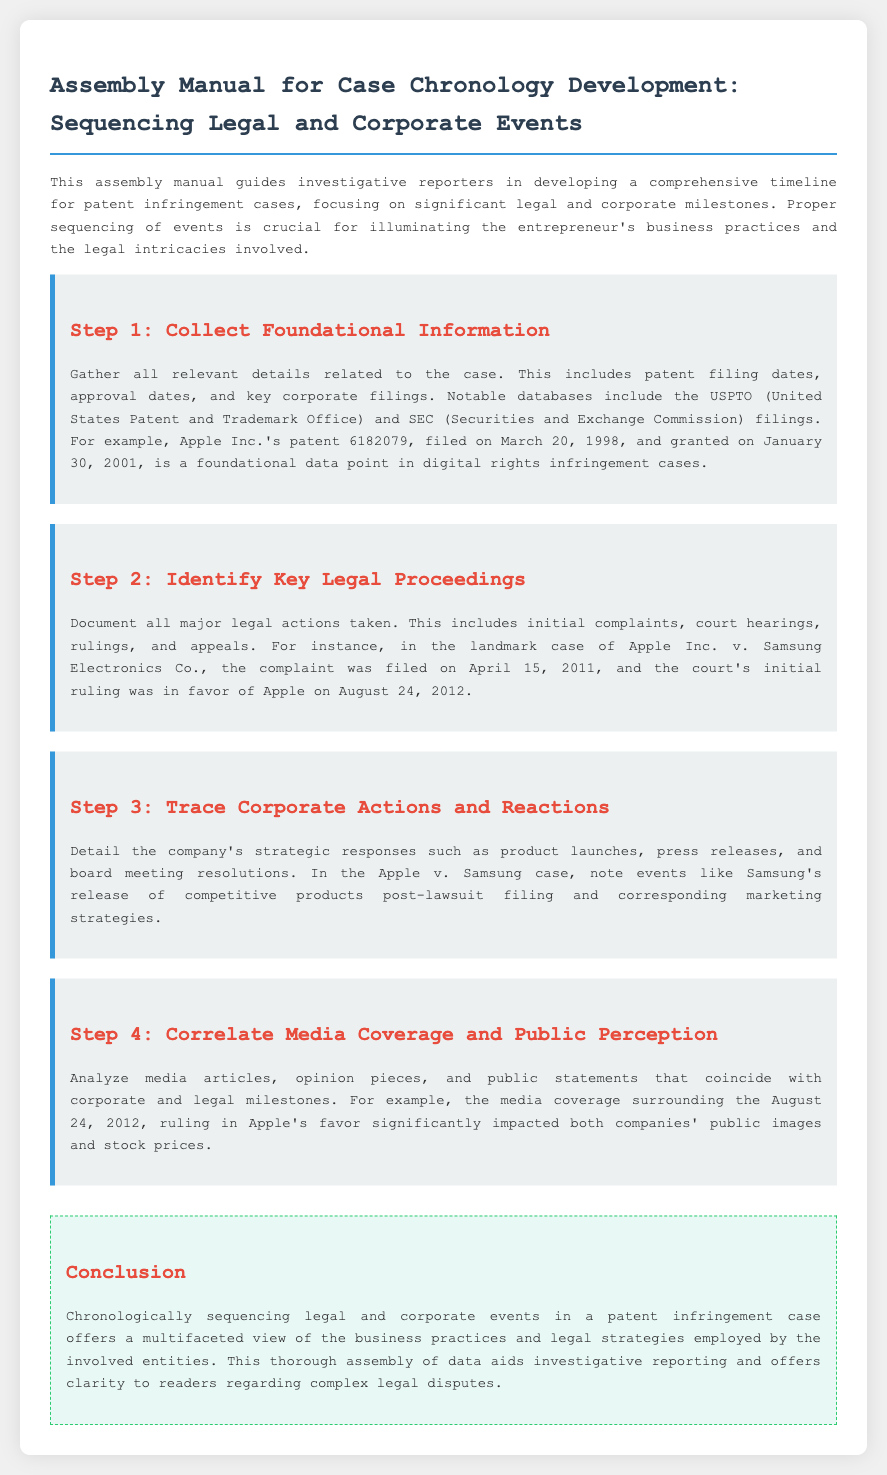What is the title of the document? The title of the document is displayed prominently at the top of the rendered document, summarizing its purpose.
Answer: Assembly Manual for Case Chronology Development: Sequencing Legal and Corporate Events What is the foundational patent number mentioned? The document provides a specific example of a patent that illustrates foundational data point in digital rights infringement cases.
Answer: 6182079 When was the initial complaint filed in Apple Inc. v. Samsung Electronics Co.? The document highlights significant dates including the filing of initial complaints in legal cases.
Answer: April 15, 2011 What type of strategic responses are documented in Step 3? The document specifies the types of corporate actions that should be detailed in this step of the assembly instructions.
Answer: Product launches What does the analysis of media coverage correlate with? The document discusses the relationship that media analysis should hold in relation to corporate and legal milestones.
Answer: Public perception What was the court's initial ruling date in favor of Apple? This date represents a significant legal milestone in the patent infringement case discussed in the document.
Answer: August 24, 2012 What is the purpose of the assembly manual? The introductory paragraph clarifies the primary aim of the manual.
Answer: Developing a comprehensive timeline for patent infringement cases What type of document is this? Understanding the nature of the document helps clarify its intent and audience.
Answer: Assembly instructions 